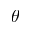<formula> <loc_0><loc_0><loc_500><loc_500>\theta</formula> 